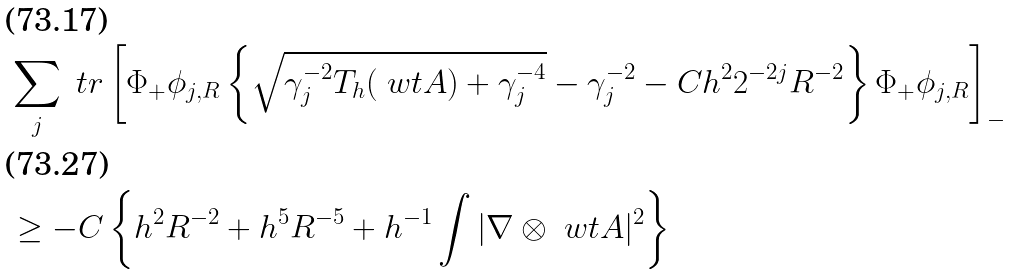Convert formula to latex. <formula><loc_0><loc_0><loc_500><loc_500>& \sum _ { j } \ t r \left [ \Phi _ { + } \phi _ { j , R } \left \{ \sqrt { \gamma _ { j } ^ { - 2 } T _ { h } ( \ w t A ) + \gamma _ { j } ^ { - 4 } } - \gamma _ { j } ^ { - 2 } - C h ^ { 2 } 2 ^ { - 2 j } R ^ { - 2 } \right \} \Phi _ { + } \phi _ { j , R } \right ] _ { - } \\ & \geq - C \left \{ h ^ { 2 } R ^ { - 2 } + h ^ { 5 } R ^ { - 5 } + h ^ { - 1 } \int | \nabla \otimes \ w t A | ^ { 2 } \right \}</formula> 